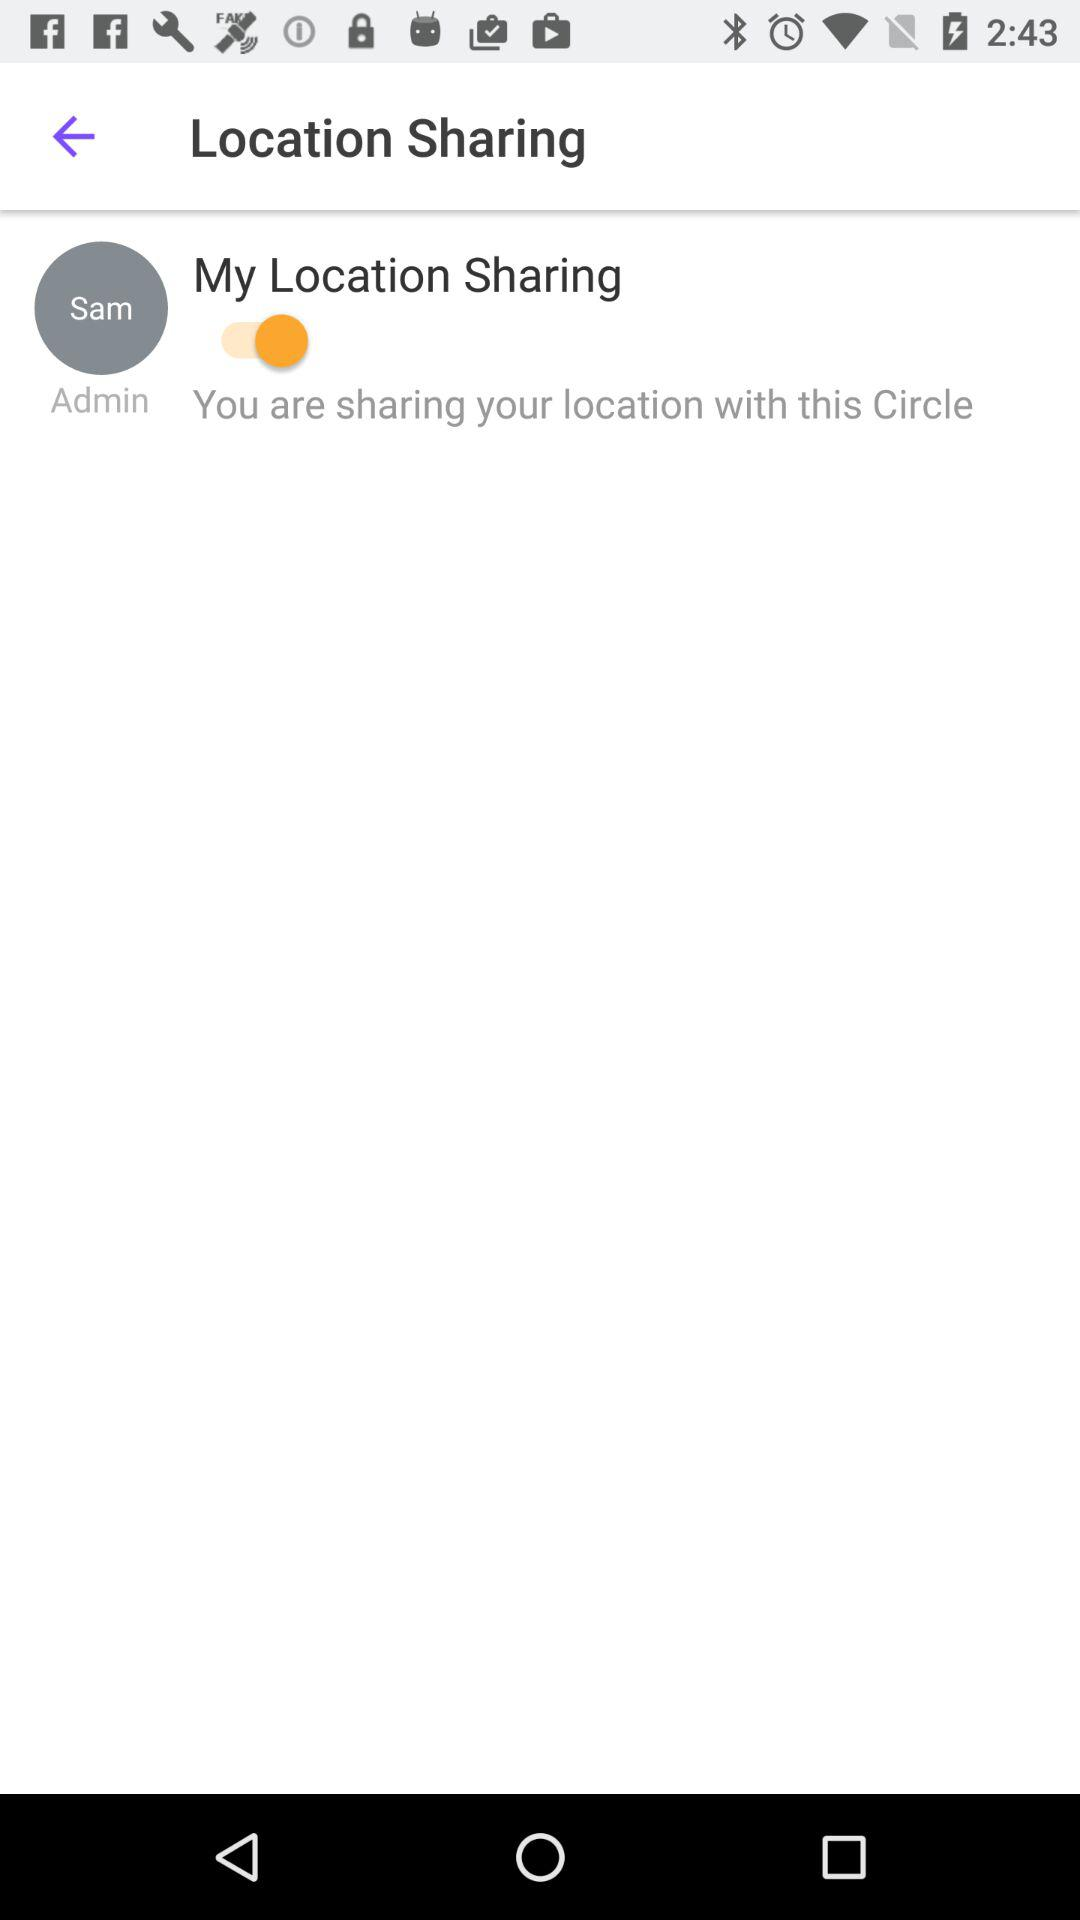Where is Sam located?
When the provided information is insufficient, respond with <no answer>. <no answer> 